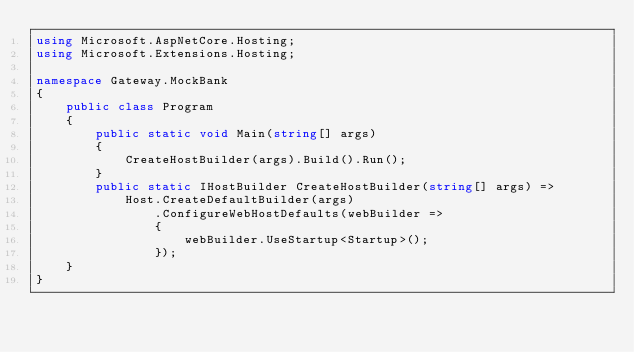<code> <loc_0><loc_0><loc_500><loc_500><_C#_>using Microsoft.AspNetCore.Hosting;
using Microsoft.Extensions.Hosting;

namespace Gateway.MockBank
{
    public class Program
    {
        public static void Main(string[] args)
        {
            CreateHostBuilder(args).Build().Run();
        }
        public static IHostBuilder CreateHostBuilder(string[] args) =>
            Host.CreateDefaultBuilder(args)
                .ConfigureWebHostDefaults(webBuilder =>
                {
                    webBuilder.UseStartup<Startup>();
                });
    }
}</code> 